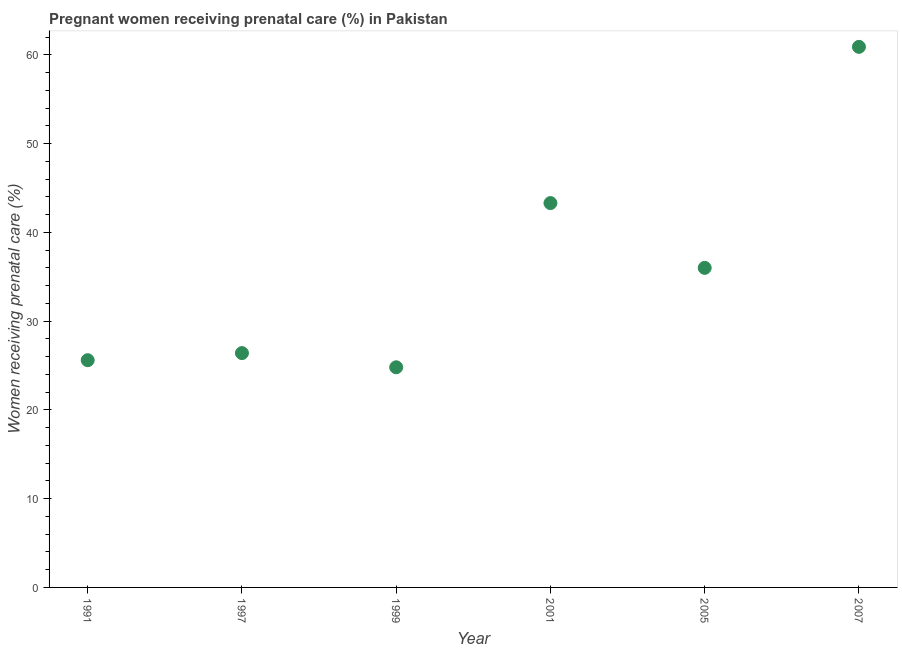What is the percentage of pregnant women receiving prenatal care in 1997?
Your response must be concise. 26.4. Across all years, what is the maximum percentage of pregnant women receiving prenatal care?
Provide a succinct answer. 60.9. Across all years, what is the minimum percentage of pregnant women receiving prenatal care?
Your response must be concise. 24.8. In which year was the percentage of pregnant women receiving prenatal care maximum?
Your answer should be very brief. 2007. What is the sum of the percentage of pregnant women receiving prenatal care?
Your answer should be very brief. 217. What is the average percentage of pregnant women receiving prenatal care per year?
Provide a succinct answer. 36.17. What is the median percentage of pregnant women receiving prenatal care?
Offer a terse response. 31.2. What is the ratio of the percentage of pregnant women receiving prenatal care in 1997 to that in 2005?
Offer a terse response. 0.73. Is the percentage of pregnant women receiving prenatal care in 1997 less than that in 2005?
Provide a short and direct response. Yes. Is the difference between the percentage of pregnant women receiving prenatal care in 1991 and 2001 greater than the difference between any two years?
Make the answer very short. No. What is the difference between the highest and the second highest percentage of pregnant women receiving prenatal care?
Offer a terse response. 17.6. Is the sum of the percentage of pregnant women receiving prenatal care in 1991 and 1999 greater than the maximum percentage of pregnant women receiving prenatal care across all years?
Offer a very short reply. No. What is the difference between the highest and the lowest percentage of pregnant women receiving prenatal care?
Provide a succinct answer. 36.1. Does the percentage of pregnant women receiving prenatal care monotonically increase over the years?
Your response must be concise. No. Does the graph contain any zero values?
Offer a terse response. No. Does the graph contain grids?
Offer a terse response. No. What is the title of the graph?
Make the answer very short. Pregnant women receiving prenatal care (%) in Pakistan. What is the label or title of the X-axis?
Provide a succinct answer. Year. What is the label or title of the Y-axis?
Your answer should be compact. Women receiving prenatal care (%). What is the Women receiving prenatal care (%) in 1991?
Provide a short and direct response. 25.6. What is the Women receiving prenatal care (%) in 1997?
Your response must be concise. 26.4. What is the Women receiving prenatal care (%) in 1999?
Make the answer very short. 24.8. What is the Women receiving prenatal care (%) in 2001?
Provide a succinct answer. 43.3. What is the Women receiving prenatal care (%) in 2007?
Give a very brief answer. 60.9. What is the difference between the Women receiving prenatal care (%) in 1991 and 1997?
Provide a succinct answer. -0.8. What is the difference between the Women receiving prenatal care (%) in 1991 and 1999?
Offer a very short reply. 0.8. What is the difference between the Women receiving prenatal care (%) in 1991 and 2001?
Provide a succinct answer. -17.7. What is the difference between the Women receiving prenatal care (%) in 1991 and 2005?
Give a very brief answer. -10.4. What is the difference between the Women receiving prenatal care (%) in 1991 and 2007?
Your answer should be compact. -35.3. What is the difference between the Women receiving prenatal care (%) in 1997 and 2001?
Provide a succinct answer. -16.9. What is the difference between the Women receiving prenatal care (%) in 1997 and 2007?
Your answer should be compact. -34.5. What is the difference between the Women receiving prenatal care (%) in 1999 and 2001?
Provide a short and direct response. -18.5. What is the difference between the Women receiving prenatal care (%) in 1999 and 2005?
Offer a terse response. -11.2. What is the difference between the Women receiving prenatal care (%) in 1999 and 2007?
Offer a terse response. -36.1. What is the difference between the Women receiving prenatal care (%) in 2001 and 2007?
Provide a succinct answer. -17.6. What is the difference between the Women receiving prenatal care (%) in 2005 and 2007?
Give a very brief answer. -24.9. What is the ratio of the Women receiving prenatal care (%) in 1991 to that in 1997?
Offer a terse response. 0.97. What is the ratio of the Women receiving prenatal care (%) in 1991 to that in 1999?
Give a very brief answer. 1.03. What is the ratio of the Women receiving prenatal care (%) in 1991 to that in 2001?
Provide a short and direct response. 0.59. What is the ratio of the Women receiving prenatal care (%) in 1991 to that in 2005?
Your answer should be very brief. 0.71. What is the ratio of the Women receiving prenatal care (%) in 1991 to that in 2007?
Offer a terse response. 0.42. What is the ratio of the Women receiving prenatal care (%) in 1997 to that in 1999?
Your response must be concise. 1.06. What is the ratio of the Women receiving prenatal care (%) in 1997 to that in 2001?
Offer a very short reply. 0.61. What is the ratio of the Women receiving prenatal care (%) in 1997 to that in 2005?
Keep it short and to the point. 0.73. What is the ratio of the Women receiving prenatal care (%) in 1997 to that in 2007?
Give a very brief answer. 0.43. What is the ratio of the Women receiving prenatal care (%) in 1999 to that in 2001?
Offer a terse response. 0.57. What is the ratio of the Women receiving prenatal care (%) in 1999 to that in 2005?
Offer a terse response. 0.69. What is the ratio of the Women receiving prenatal care (%) in 1999 to that in 2007?
Your answer should be very brief. 0.41. What is the ratio of the Women receiving prenatal care (%) in 2001 to that in 2005?
Provide a succinct answer. 1.2. What is the ratio of the Women receiving prenatal care (%) in 2001 to that in 2007?
Your answer should be very brief. 0.71. What is the ratio of the Women receiving prenatal care (%) in 2005 to that in 2007?
Make the answer very short. 0.59. 